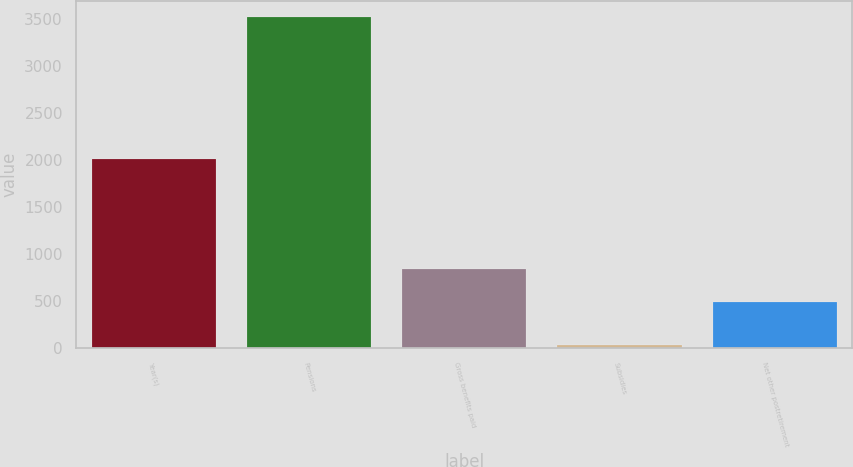<chart> <loc_0><loc_0><loc_500><loc_500><bar_chart><fcel>Year(s)<fcel>Pensions<fcel>Gross benefits paid<fcel>Subsidies<fcel>Net other postretirement<nl><fcel>2016<fcel>3522<fcel>846.1<fcel>41<fcel>498<nl></chart> 